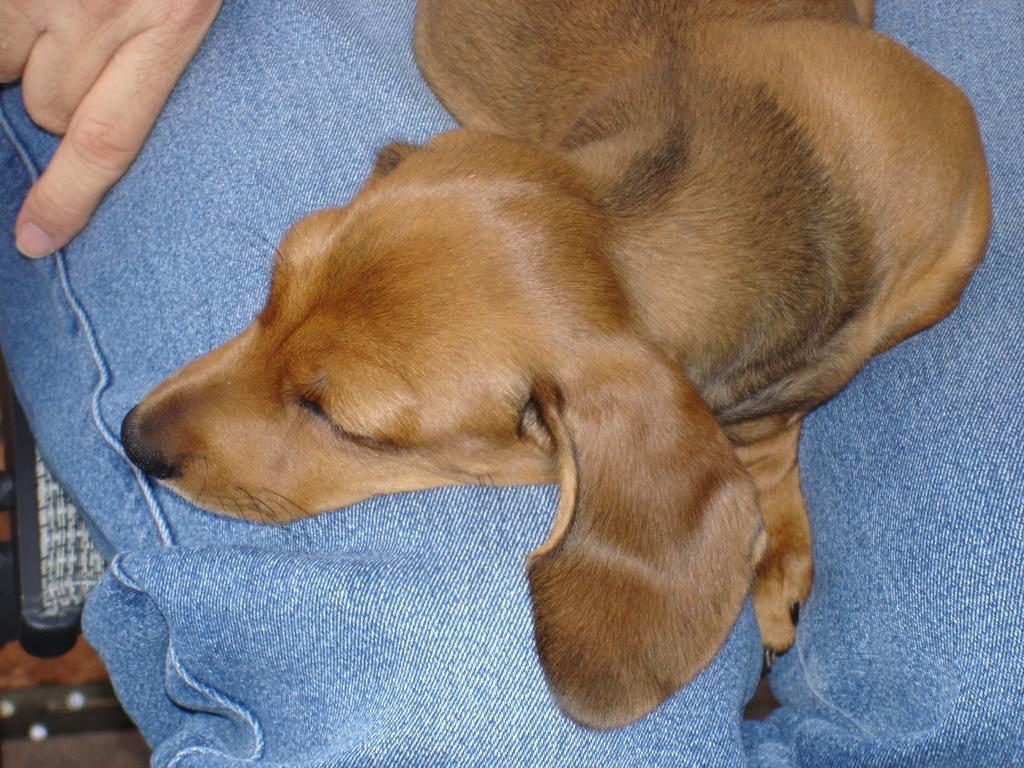Describe this image in one or two sentences. Here in this picture we can see a dog lying on a person's lap, who is sitting over a place. 